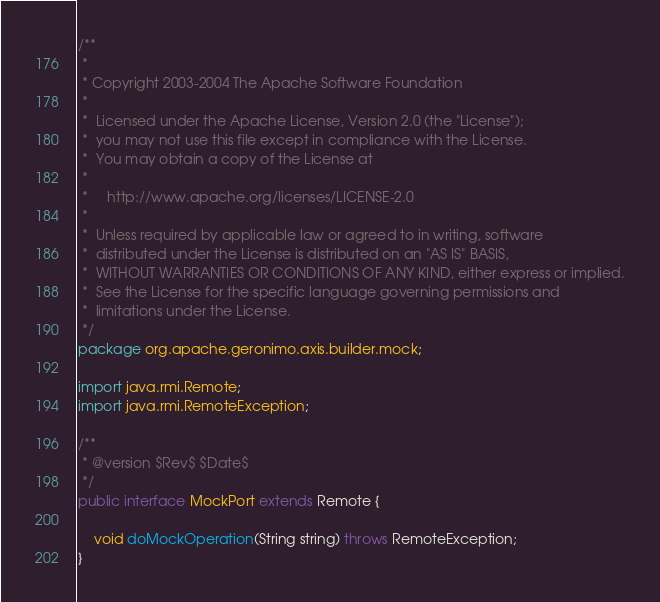Convert code to text. <code><loc_0><loc_0><loc_500><loc_500><_Java_>/**
 *
 * Copyright 2003-2004 The Apache Software Foundation
 *
 *  Licensed under the Apache License, Version 2.0 (the "License");
 *  you may not use this file except in compliance with the License.
 *  You may obtain a copy of the License at
 *
 *     http://www.apache.org/licenses/LICENSE-2.0
 *
 *  Unless required by applicable law or agreed to in writing, software
 *  distributed under the License is distributed on an "AS IS" BASIS,
 *  WITHOUT WARRANTIES OR CONDITIONS OF ANY KIND, either express or implied.
 *  See the License for the specific language governing permissions and
 *  limitations under the License.
 */
package org.apache.geronimo.axis.builder.mock;

import java.rmi.Remote;
import java.rmi.RemoteException;

/**
 * @version $Rev$ $Date$
 */
public interface MockPort extends Remote {

    void doMockOperation(String string) throws RemoteException;
}
</code> 